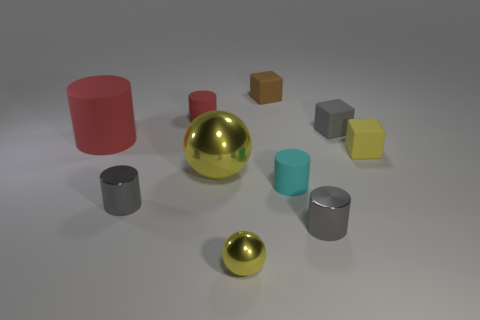Subtract all small gray metallic cylinders. How many cylinders are left? 3 Subtract all blue blocks. How many gray cylinders are left? 2 Subtract 3 cylinders. How many cylinders are left? 2 Subtract all cyan cylinders. How many cylinders are left? 4 Subtract all balls. How many objects are left? 8 Subtract all green cubes. Subtract all brown spheres. How many cubes are left? 3 Subtract all small brown rubber blocks. Subtract all large yellow metallic things. How many objects are left? 8 Add 5 tiny yellow matte blocks. How many tiny yellow matte blocks are left? 6 Add 8 tiny metal cylinders. How many tiny metal cylinders exist? 10 Subtract 0 green cylinders. How many objects are left? 10 